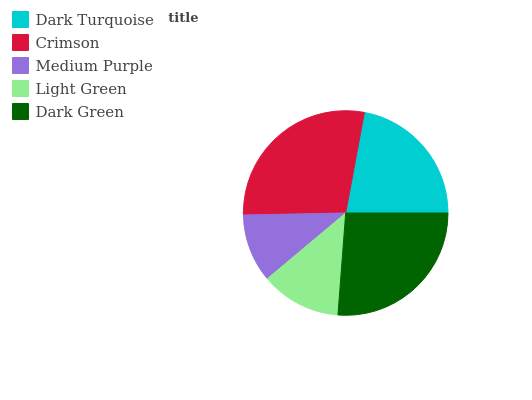Is Medium Purple the minimum?
Answer yes or no. Yes. Is Crimson the maximum?
Answer yes or no. Yes. Is Crimson the minimum?
Answer yes or no. No. Is Medium Purple the maximum?
Answer yes or no. No. Is Crimson greater than Medium Purple?
Answer yes or no. Yes. Is Medium Purple less than Crimson?
Answer yes or no. Yes. Is Medium Purple greater than Crimson?
Answer yes or no. No. Is Crimson less than Medium Purple?
Answer yes or no. No. Is Dark Turquoise the high median?
Answer yes or no. Yes. Is Dark Turquoise the low median?
Answer yes or no. Yes. Is Light Green the high median?
Answer yes or no. No. Is Medium Purple the low median?
Answer yes or no. No. 